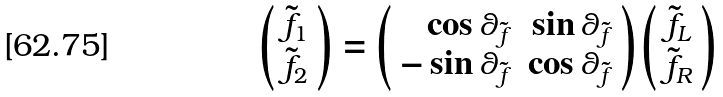<formula> <loc_0><loc_0><loc_500><loc_500>\left ( \begin{array} { c } \tilde { f } _ { 1 } \\ \tilde { f } _ { 2 } \end{array} \right ) = \left ( \begin{array} { r r } \cos \theta _ { \tilde { f } } & \sin \theta _ { \tilde { f } } \\ - \sin \theta _ { \tilde { f } } & \cos \theta _ { \tilde { f } } \end{array} \right ) \left ( \begin{array} { c } \tilde { f } _ { L } \\ \tilde { f } _ { R } \end{array} \right )</formula> 